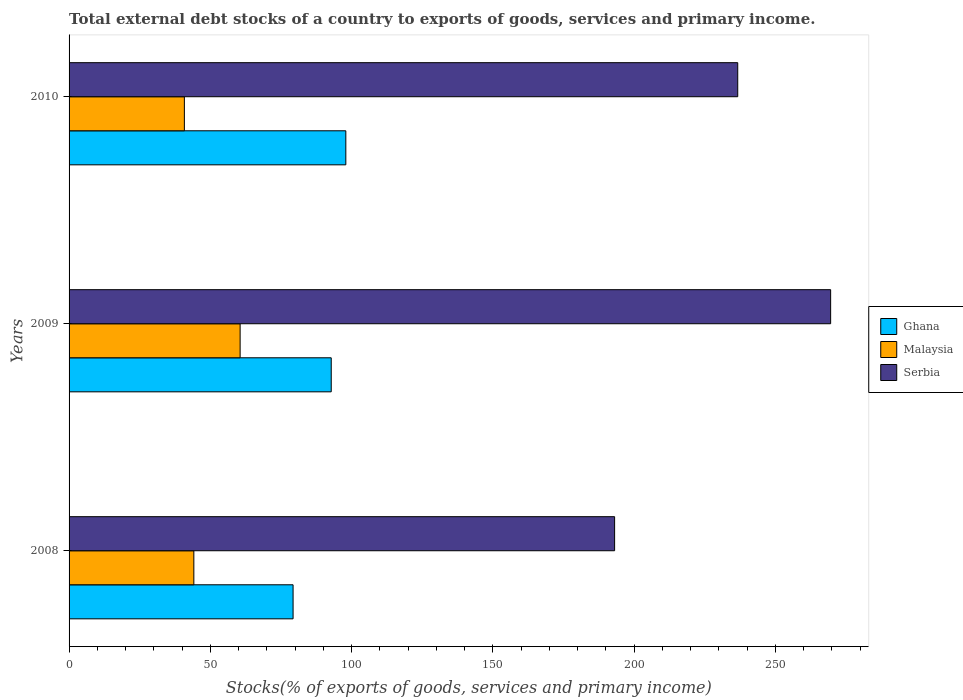How many different coloured bars are there?
Keep it short and to the point. 3. How many groups of bars are there?
Provide a short and direct response. 3. How many bars are there on the 2nd tick from the top?
Provide a short and direct response. 3. How many bars are there on the 1st tick from the bottom?
Make the answer very short. 3. What is the total debt stocks in Serbia in 2009?
Keep it short and to the point. 269.55. Across all years, what is the maximum total debt stocks in Serbia?
Make the answer very short. 269.55. Across all years, what is the minimum total debt stocks in Ghana?
Your response must be concise. 79.29. In which year was the total debt stocks in Serbia maximum?
Provide a short and direct response. 2009. In which year was the total debt stocks in Serbia minimum?
Keep it short and to the point. 2008. What is the total total debt stocks in Malaysia in the graph?
Offer a very short reply. 145.52. What is the difference between the total debt stocks in Malaysia in 2008 and that in 2010?
Offer a very short reply. 3.35. What is the difference between the total debt stocks in Malaysia in 2010 and the total debt stocks in Ghana in 2008?
Offer a terse response. -38.48. What is the average total debt stocks in Malaysia per year?
Provide a succinct answer. 48.51. In the year 2009, what is the difference between the total debt stocks in Ghana and total debt stocks in Malaysia?
Give a very brief answer. 32.25. In how many years, is the total debt stocks in Serbia greater than 170 %?
Your answer should be compact. 3. What is the ratio of the total debt stocks in Ghana in 2008 to that in 2010?
Offer a terse response. 0.81. Is the total debt stocks in Serbia in 2009 less than that in 2010?
Your answer should be very brief. No. Is the difference between the total debt stocks in Ghana in 2008 and 2010 greater than the difference between the total debt stocks in Malaysia in 2008 and 2010?
Provide a short and direct response. No. What is the difference between the highest and the second highest total debt stocks in Serbia?
Your response must be concise. 32.89. What is the difference between the highest and the lowest total debt stocks in Serbia?
Keep it short and to the point. 76.47. Is the sum of the total debt stocks in Ghana in 2009 and 2010 greater than the maximum total debt stocks in Malaysia across all years?
Provide a short and direct response. Yes. What does the 1st bar from the top in 2010 represents?
Give a very brief answer. Serbia. What does the 2nd bar from the bottom in 2009 represents?
Give a very brief answer. Malaysia. How many years are there in the graph?
Your answer should be very brief. 3. Are the values on the major ticks of X-axis written in scientific E-notation?
Offer a terse response. No. Does the graph contain grids?
Provide a succinct answer. No. How are the legend labels stacked?
Give a very brief answer. Vertical. What is the title of the graph?
Keep it short and to the point. Total external debt stocks of a country to exports of goods, services and primary income. What is the label or title of the X-axis?
Provide a short and direct response. Stocks(% of exports of goods, services and primary income). What is the label or title of the Y-axis?
Make the answer very short. Years. What is the Stocks(% of exports of goods, services and primary income) of Ghana in 2008?
Offer a very short reply. 79.29. What is the Stocks(% of exports of goods, services and primary income) of Malaysia in 2008?
Provide a succinct answer. 44.16. What is the Stocks(% of exports of goods, services and primary income) of Serbia in 2008?
Ensure brevity in your answer.  193.09. What is the Stocks(% of exports of goods, services and primary income) of Ghana in 2009?
Your response must be concise. 92.79. What is the Stocks(% of exports of goods, services and primary income) in Malaysia in 2009?
Make the answer very short. 60.54. What is the Stocks(% of exports of goods, services and primary income) in Serbia in 2009?
Keep it short and to the point. 269.55. What is the Stocks(% of exports of goods, services and primary income) of Ghana in 2010?
Ensure brevity in your answer.  97.96. What is the Stocks(% of exports of goods, services and primary income) in Malaysia in 2010?
Your answer should be compact. 40.81. What is the Stocks(% of exports of goods, services and primary income) of Serbia in 2010?
Ensure brevity in your answer.  236.67. Across all years, what is the maximum Stocks(% of exports of goods, services and primary income) in Ghana?
Provide a short and direct response. 97.96. Across all years, what is the maximum Stocks(% of exports of goods, services and primary income) of Malaysia?
Keep it short and to the point. 60.54. Across all years, what is the maximum Stocks(% of exports of goods, services and primary income) in Serbia?
Your answer should be compact. 269.55. Across all years, what is the minimum Stocks(% of exports of goods, services and primary income) in Ghana?
Keep it short and to the point. 79.29. Across all years, what is the minimum Stocks(% of exports of goods, services and primary income) in Malaysia?
Offer a very short reply. 40.81. Across all years, what is the minimum Stocks(% of exports of goods, services and primary income) in Serbia?
Offer a terse response. 193.09. What is the total Stocks(% of exports of goods, services and primary income) in Ghana in the graph?
Offer a terse response. 270.03. What is the total Stocks(% of exports of goods, services and primary income) of Malaysia in the graph?
Provide a succinct answer. 145.52. What is the total Stocks(% of exports of goods, services and primary income) in Serbia in the graph?
Your answer should be very brief. 699.31. What is the difference between the Stocks(% of exports of goods, services and primary income) in Ghana in 2008 and that in 2009?
Keep it short and to the point. -13.5. What is the difference between the Stocks(% of exports of goods, services and primary income) in Malaysia in 2008 and that in 2009?
Your answer should be compact. -16.38. What is the difference between the Stocks(% of exports of goods, services and primary income) of Serbia in 2008 and that in 2009?
Offer a terse response. -76.47. What is the difference between the Stocks(% of exports of goods, services and primary income) of Ghana in 2008 and that in 2010?
Give a very brief answer. -18.67. What is the difference between the Stocks(% of exports of goods, services and primary income) of Malaysia in 2008 and that in 2010?
Provide a short and direct response. 3.35. What is the difference between the Stocks(% of exports of goods, services and primary income) in Serbia in 2008 and that in 2010?
Your response must be concise. -43.58. What is the difference between the Stocks(% of exports of goods, services and primary income) in Ghana in 2009 and that in 2010?
Provide a succinct answer. -5.16. What is the difference between the Stocks(% of exports of goods, services and primary income) of Malaysia in 2009 and that in 2010?
Your response must be concise. 19.73. What is the difference between the Stocks(% of exports of goods, services and primary income) of Serbia in 2009 and that in 2010?
Offer a terse response. 32.89. What is the difference between the Stocks(% of exports of goods, services and primary income) in Ghana in 2008 and the Stocks(% of exports of goods, services and primary income) in Malaysia in 2009?
Keep it short and to the point. 18.74. What is the difference between the Stocks(% of exports of goods, services and primary income) of Ghana in 2008 and the Stocks(% of exports of goods, services and primary income) of Serbia in 2009?
Provide a short and direct response. -190.27. What is the difference between the Stocks(% of exports of goods, services and primary income) of Malaysia in 2008 and the Stocks(% of exports of goods, services and primary income) of Serbia in 2009?
Make the answer very short. -225.39. What is the difference between the Stocks(% of exports of goods, services and primary income) of Ghana in 2008 and the Stocks(% of exports of goods, services and primary income) of Malaysia in 2010?
Offer a very short reply. 38.48. What is the difference between the Stocks(% of exports of goods, services and primary income) of Ghana in 2008 and the Stocks(% of exports of goods, services and primary income) of Serbia in 2010?
Ensure brevity in your answer.  -157.38. What is the difference between the Stocks(% of exports of goods, services and primary income) in Malaysia in 2008 and the Stocks(% of exports of goods, services and primary income) in Serbia in 2010?
Give a very brief answer. -192.51. What is the difference between the Stocks(% of exports of goods, services and primary income) of Ghana in 2009 and the Stocks(% of exports of goods, services and primary income) of Malaysia in 2010?
Ensure brevity in your answer.  51.98. What is the difference between the Stocks(% of exports of goods, services and primary income) in Ghana in 2009 and the Stocks(% of exports of goods, services and primary income) in Serbia in 2010?
Offer a terse response. -143.88. What is the difference between the Stocks(% of exports of goods, services and primary income) in Malaysia in 2009 and the Stocks(% of exports of goods, services and primary income) in Serbia in 2010?
Your answer should be compact. -176.13. What is the average Stocks(% of exports of goods, services and primary income) in Ghana per year?
Your response must be concise. 90.01. What is the average Stocks(% of exports of goods, services and primary income) in Malaysia per year?
Make the answer very short. 48.51. What is the average Stocks(% of exports of goods, services and primary income) in Serbia per year?
Offer a very short reply. 233.1. In the year 2008, what is the difference between the Stocks(% of exports of goods, services and primary income) in Ghana and Stocks(% of exports of goods, services and primary income) in Malaysia?
Provide a succinct answer. 35.13. In the year 2008, what is the difference between the Stocks(% of exports of goods, services and primary income) in Ghana and Stocks(% of exports of goods, services and primary income) in Serbia?
Keep it short and to the point. -113.8. In the year 2008, what is the difference between the Stocks(% of exports of goods, services and primary income) of Malaysia and Stocks(% of exports of goods, services and primary income) of Serbia?
Give a very brief answer. -148.93. In the year 2009, what is the difference between the Stocks(% of exports of goods, services and primary income) in Ghana and Stocks(% of exports of goods, services and primary income) in Malaysia?
Keep it short and to the point. 32.25. In the year 2009, what is the difference between the Stocks(% of exports of goods, services and primary income) of Ghana and Stocks(% of exports of goods, services and primary income) of Serbia?
Give a very brief answer. -176.76. In the year 2009, what is the difference between the Stocks(% of exports of goods, services and primary income) in Malaysia and Stocks(% of exports of goods, services and primary income) in Serbia?
Provide a short and direct response. -209.01. In the year 2010, what is the difference between the Stocks(% of exports of goods, services and primary income) in Ghana and Stocks(% of exports of goods, services and primary income) in Malaysia?
Your response must be concise. 57.14. In the year 2010, what is the difference between the Stocks(% of exports of goods, services and primary income) of Ghana and Stocks(% of exports of goods, services and primary income) of Serbia?
Offer a terse response. -138.71. In the year 2010, what is the difference between the Stocks(% of exports of goods, services and primary income) in Malaysia and Stocks(% of exports of goods, services and primary income) in Serbia?
Offer a very short reply. -195.86. What is the ratio of the Stocks(% of exports of goods, services and primary income) of Ghana in 2008 to that in 2009?
Ensure brevity in your answer.  0.85. What is the ratio of the Stocks(% of exports of goods, services and primary income) in Malaysia in 2008 to that in 2009?
Keep it short and to the point. 0.73. What is the ratio of the Stocks(% of exports of goods, services and primary income) in Serbia in 2008 to that in 2009?
Offer a very short reply. 0.72. What is the ratio of the Stocks(% of exports of goods, services and primary income) of Ghana in 2008 to that in 2010?
Make the answer very short. 0.81. What is the ratio of the Stocks(% of exports of goods, services and primary income) of Malaysia in 2008 to that in 2010?
Your answer should be compact. 1.08. What is the ratio of the Stocks(% of exports of goods, services and primary income) in Serbia in 2008 to that in 2010?
Your answer should be compact. 0.82. What is the ratio of the Stocks(% of exports of goods, services and primary income) of Ghana in 2009 to that in 2010?
Your answer should be very brief. 0.95. What is the ratio of the Stocks(% of exports of goods, services and primary income) in Malaysia in 2009 to that in 2010?
Make the answer very short. 1.48. What is the ratio of the Stocks(% of exports of goods, services and primary income) in Serbia in 2009 to that in 2010?
Provide a succinct answer. 1.14. What is the difference between the highest and the second highest Stocks(% of exports of goods, services and primary income) of Ghana?
Your answer should be very brief. 5.16. What is the difference between the highest and the second highest Stocks(% of exports of goods, services and primary income) of Malaysia?
Provide a succinct answer. 16.38. What is the difference between the highest and the second highest Stocks(% of exports of goods, services and primary income) of Serbia?
Keep it short and to the point. 32.89. What is the difference between the highest and the lowest Stocks(% of exports of goods, services and primary income) of Ghana?
Provide a short and direct response. 18.67. What is the difference between the highest and the lowest Stocks(% of exports of goods, services and primary income) of Malaysia?
Give a very brief answer. 19.73. What is the difference between the highest and the lowest Stocks(% of exports of goods, services and primary income) in Serbia?
Keep it short and to the point. 76.47. 